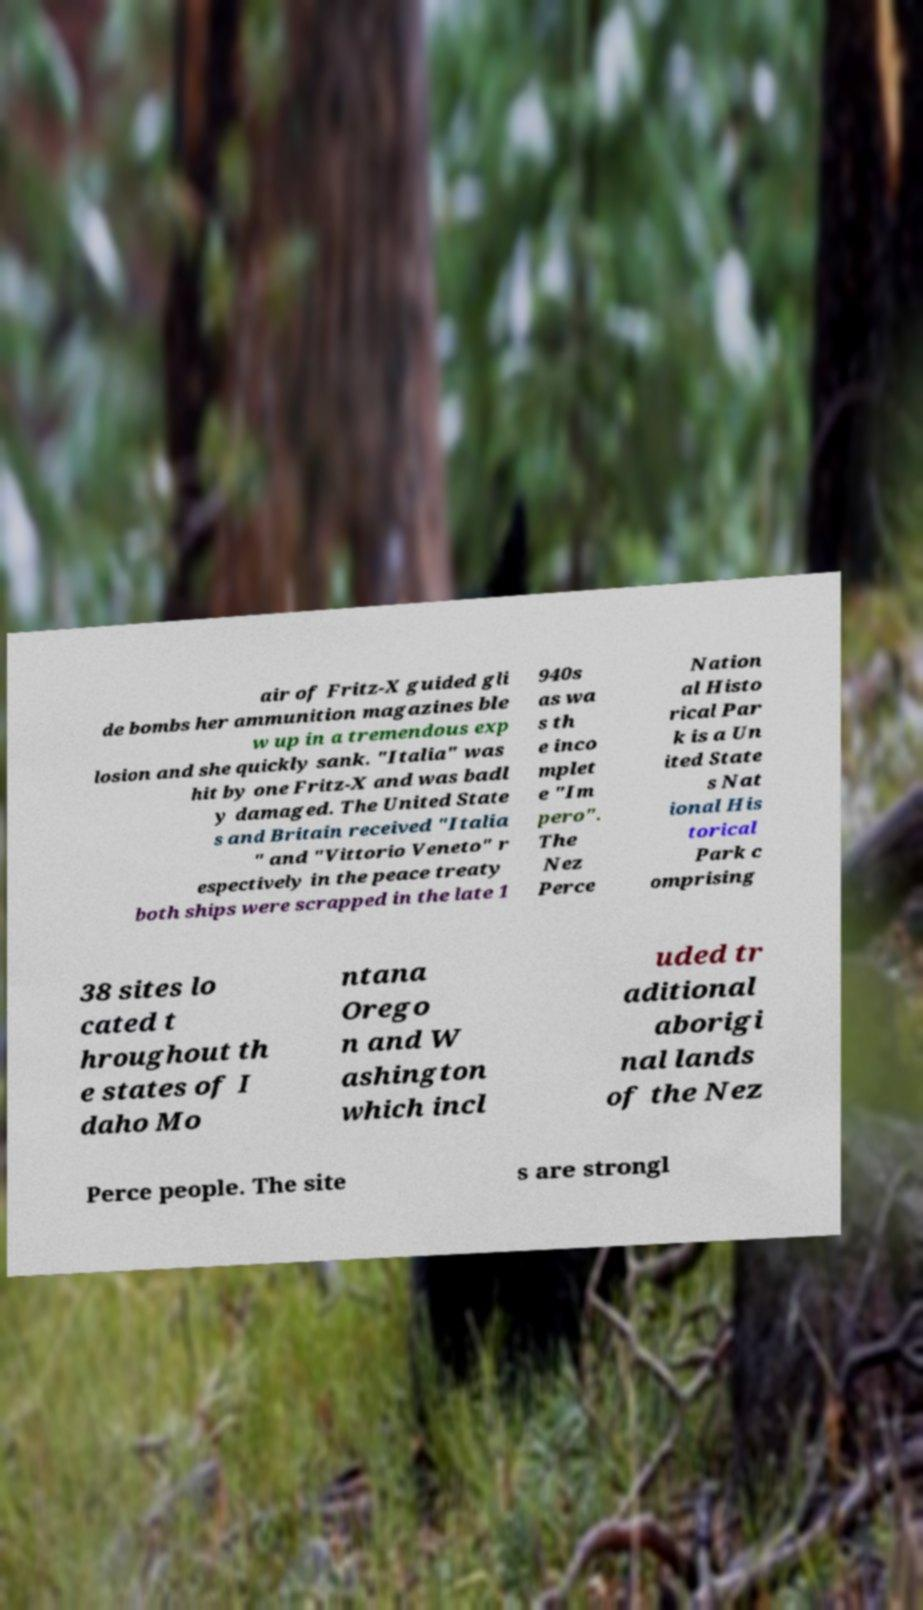I need the written content from this picture converted into text. Can you do that? air of Fritz-X guided gli de bombs her ammunition magazines ble w up in a tremendous exp losion and she quickly sank. "Italia" was hit by one Fritz-X and was badl y damaged. The United State s and Britain received "Italia " and "Vittorio Veneto" r espectively in the peace treaty both ships were scrapped in the late 1 940s as wa s th e inco mplet e "Im pero". The Nez Perce Nation al Histo rical Par k is a Un ited State s Nat ional His torical Park c omprising 38 sites lo cated t hroughout th e states of I daho Mo ntana Orego n and W ashington which incl uded tr aditional aborigi nal lands of the Nez Perce people. The site s are strongl 